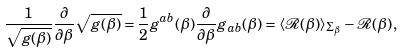Convert formula to latex. <formula><loc_0><loc_0><loc_500><loc_500>\frac { 1 } { \sqrt { g ( \beta ) } } \frac { \partial } { \partial \beta } \sqrt { g ( \beta ) } = \frac { 1 } { 2 } g ^ { a b } ( \beta ) \frac { \partial } { \partial \beta } g _ { a b } ( \beta ) = \langle \mathcal { R } ( \beta ) \rangle _ { \Sigma _ { \beta } } - \mathcal { R } ( \beta ) \, ,</formula> 